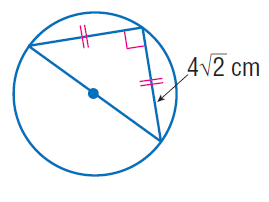Answer the mathemtical geometry problem and directly provide the correct option letter.
Question: Find the exact circumference of the circle.
Choices: A: 4 \pi B: 4 \sqrt { 2 } \pi C: 8 \pi D: 16 \pi C 